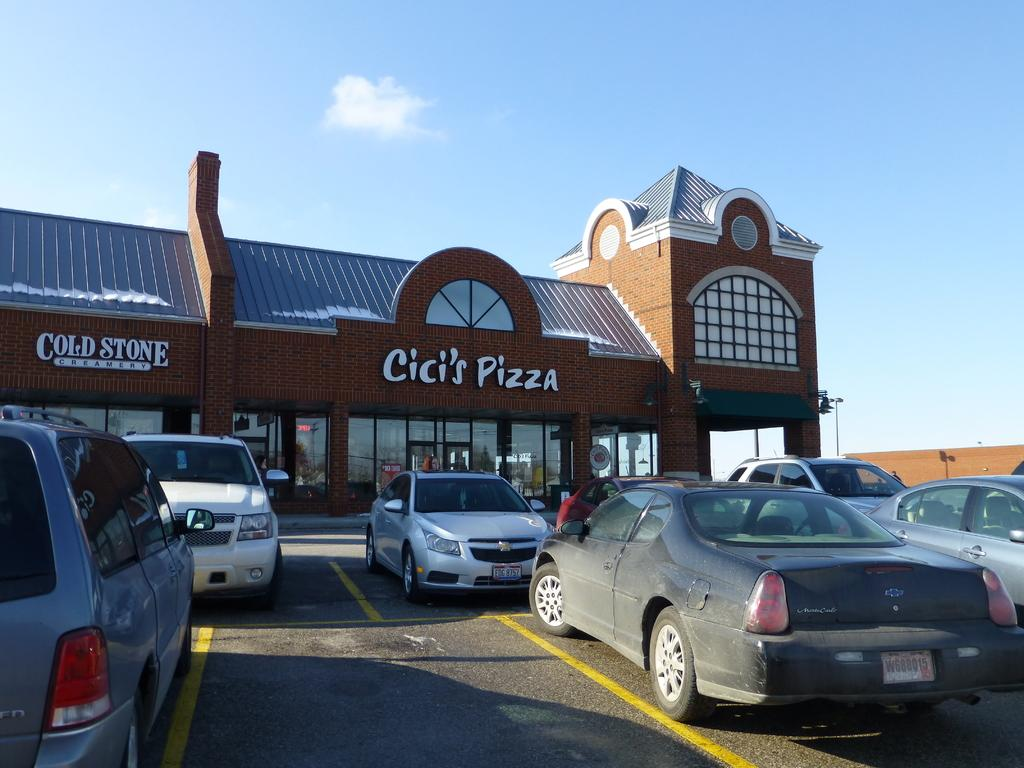What can be seen in the image related to transportation? There are cars parked in the image. What is visible in the background of the image? There is a building in the background of the image. Can you describe the building in the image? The building has a name plate and windows. What is the condition of the sky in the image? The sky is clear in the image. What type of music can be heard coming from the mine in the image? There is no mine present in the image, and therefore no music can be heard coming from it. What kind of plant is growing near the building in the image? There is no plant visible near the building in the image. 